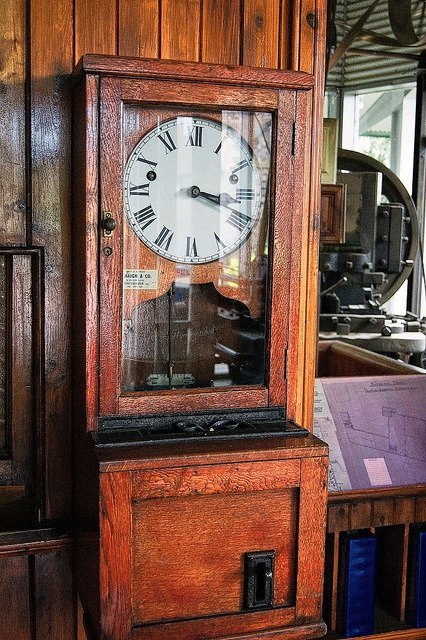Describe the objects in this image and their specific colors. I can see a clock in brown, lightgray, darkgray, and gray tones in this image. 